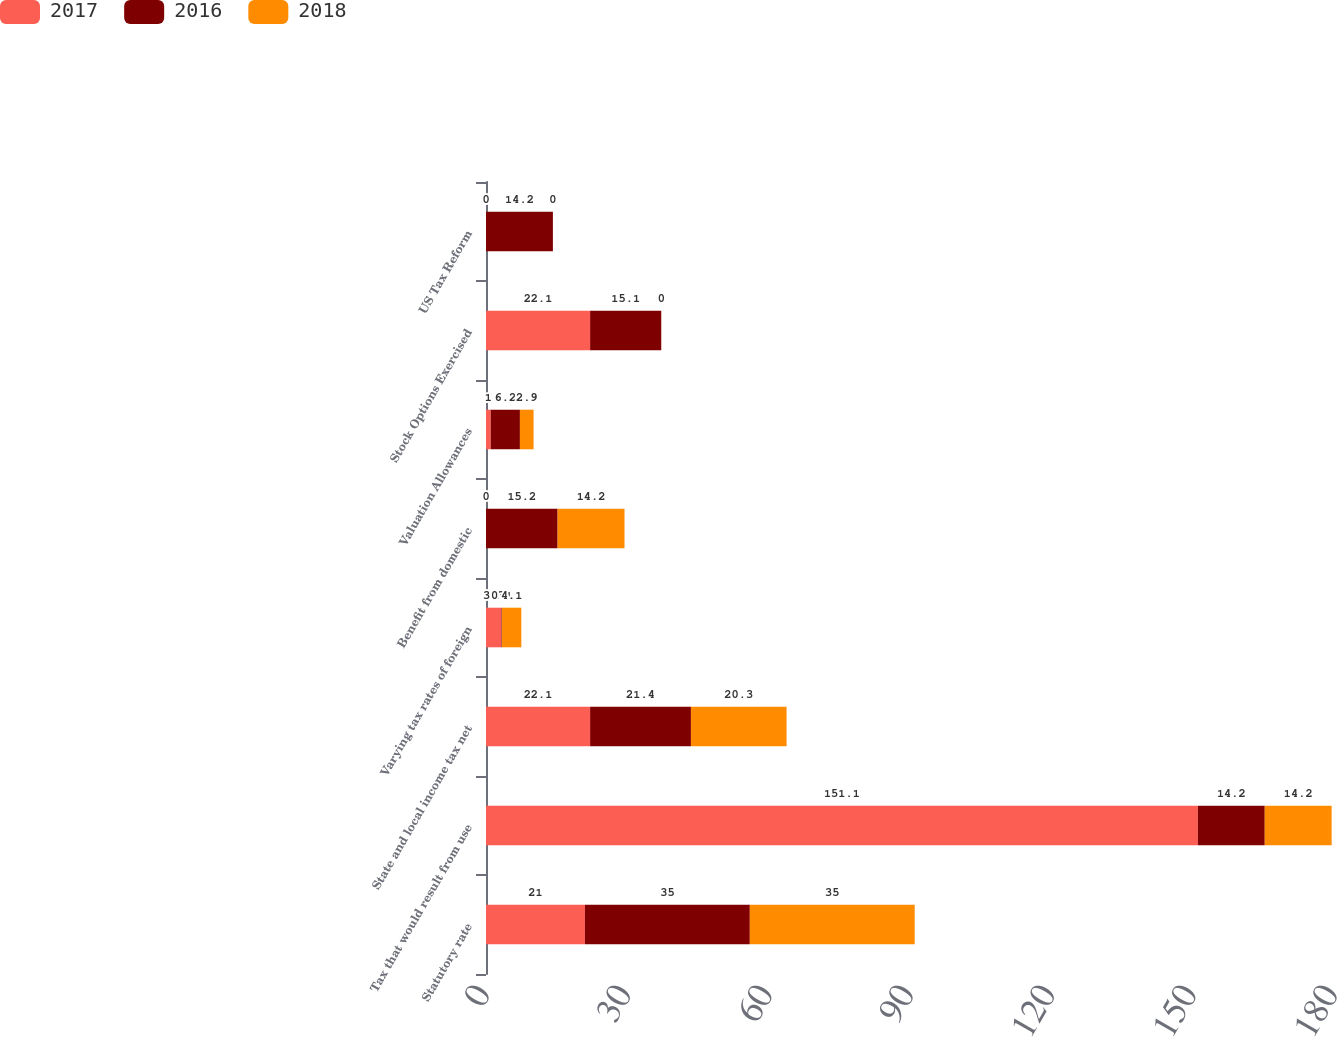Convert chart to OTSL. <chart><loc_0><loc_0><loc_500><loc_500><stacked_bar_chart><ecel><fcel>Statutory rate<fcel>Tax that would result from use<fcel>State and local income tax net<fcel>Varying tax rates of foreign<fcel>Benefit from domestic<fcel>Valuation Allowances<fcel>Stock Options Exercised<fcel>US Tax Reform<nl><fcel>2017<fcel>21<fcel>151.1<fcel>22.1<fcel>3.3<fcel>0<fcel>1<fcel>22.1<fcel>0<nl><fcel>2016<fcel>35<fcel>14.2<fcel>21.4<fcel>0.1<fcel>15.2<fcel>6.2<fcel>15.1<fcel>14.2<nl><fcel>2018<fcel>35<fcel>14.2<fcel>20.3<fcel>4.1<fcel>14.2<fcel>2.9<fcel>0<fcel>0<nl></chart> 